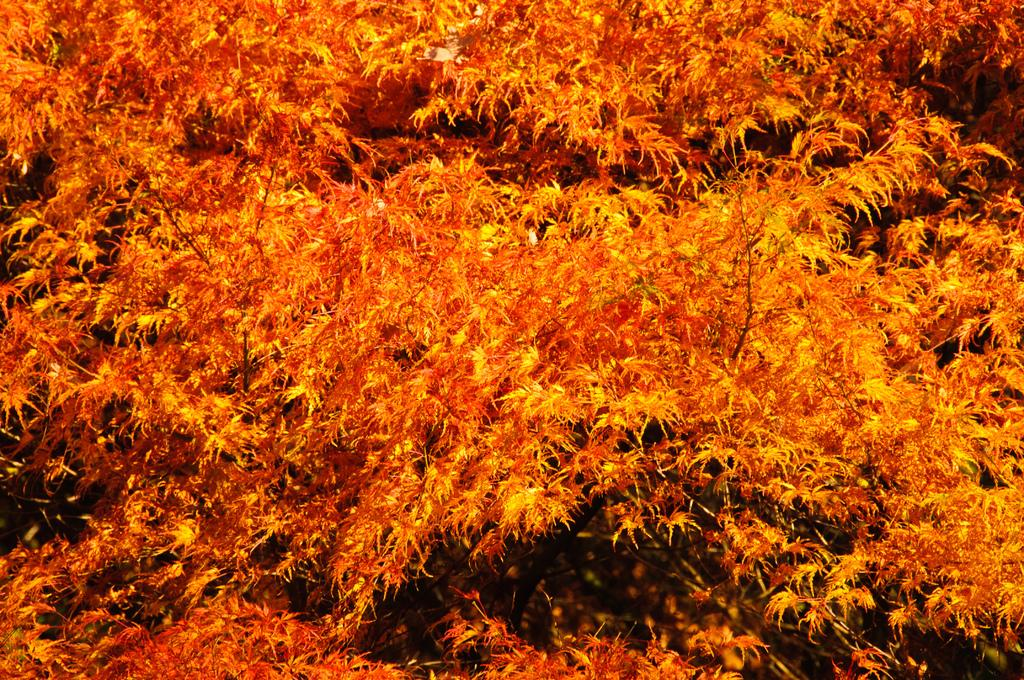What is present in the image? There is a tree in the image. Can you describe the tree in the image? The tree is orange in color. What type of beam is holding up the tree in the image? There is no beam present in the image, as the tree is standing on its own. What kind of thread is used to create the texture of the tree in the image? The image is not a drawing or painting, so there is no thread used to create the texture of the tree. 